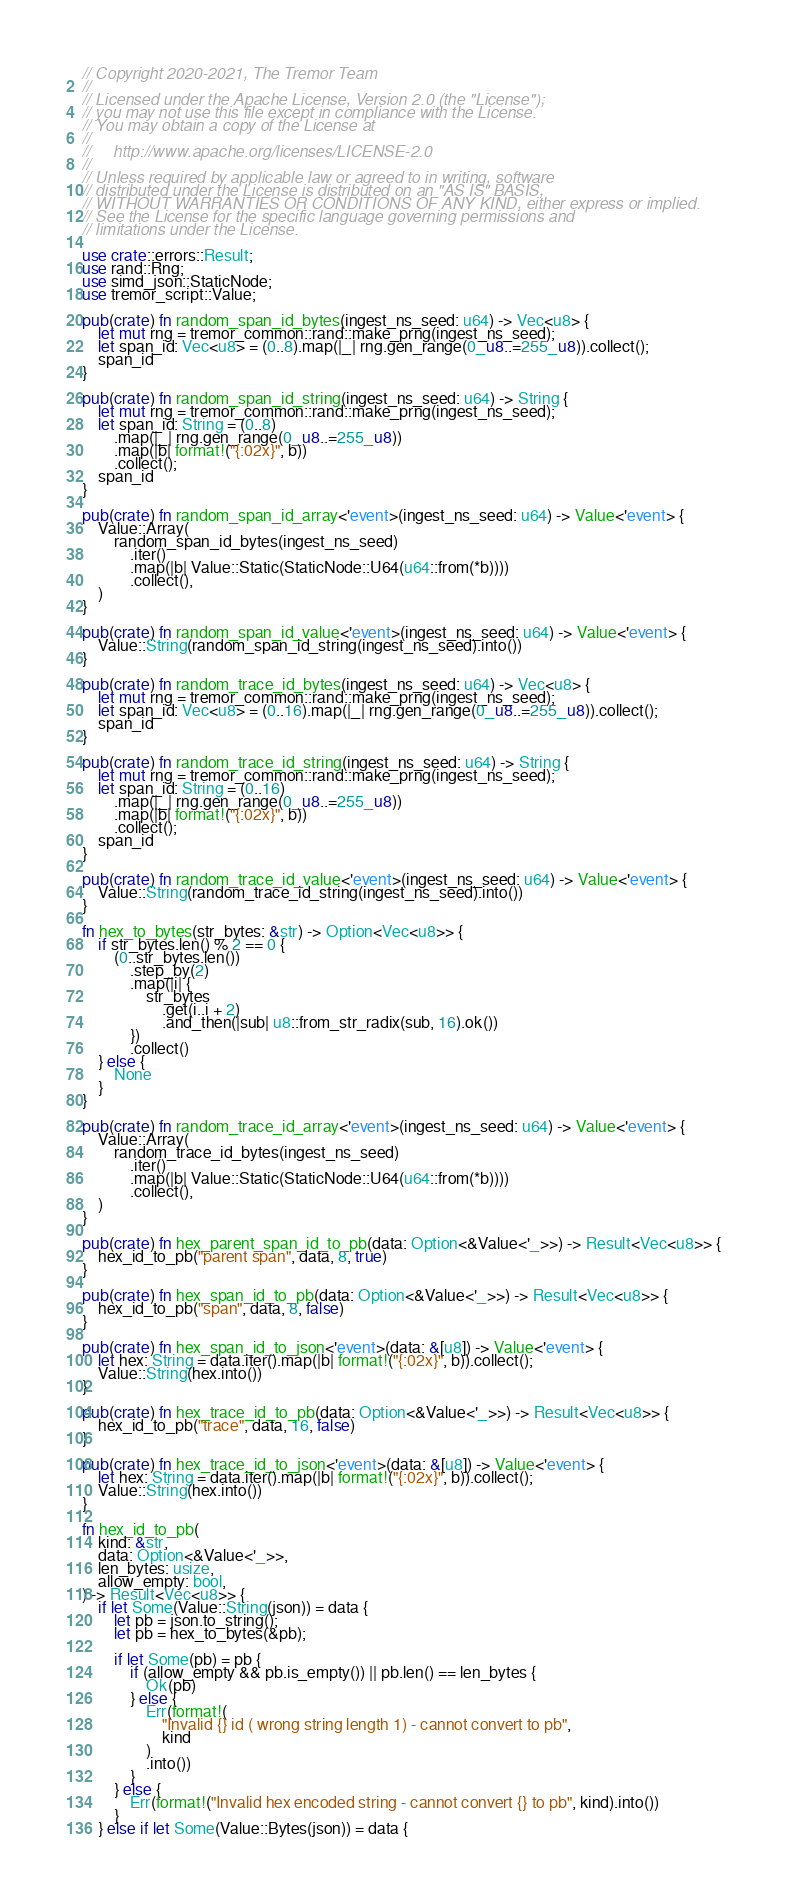<code> <loc_0><loc_0><loc_500><loc_500><_Rust_>// Copyright 2020-2021, The Tremor Team
//
// Licensed under the Apache License, Version 2.0 (the "License");
// you may not use this file except in compliance with the License.
// You may obtain a copy of the License at
//
//     http://www.apache.org/licenses/LICENSE-2.0
//
// Unless required by applicable law or agreed to in writing, software
// distributed under the License is distributed on an "AS IS" BASIS,
// WITHOUT WARRANTIES OR CONDITIONS OF ANY KIND, either express or implied.
// See the License for the specific language governing permissions and
// limitations under the License.

use crate::errors::Result;
use rand::Rng;
use simd_json::StaticNode;
use tremor_script::Value;

pub(crate) fn random_span_id_bytes(ingest_ns_seed: u64) -> Vec<u8> {
    let mut rng = tremor_common::rand::make_prng(ingest_ns_seed);
    let span_id: Vec<u8> = (0..8).map(|_| rng.gen_range(0_u8..=255_u8)).collect();
    span_id
}

pub(crate) fn random_span_id_string(ingest_ns_seed: u64) -> String {
    let mut rng = tremor_common::rand::make_prng(ingest_ns_seed);
    let span_id: String = (0..8)
        .map(|_| rng.gen_range(0_u8..=255_u8))
        .map(|b| format!("{:02x}", b))
        .collect();
    span_id
}

pub(crate) fn random_span_id_array<'event>(ingest_ns_seed: u64) -> Value<'event> {
    Value::Array(
        random_span_id_bytes(ingest_ns_seed)
            .iter()
            .map(|b| Value::Static(StaticNode::U64(u64::from(*b))))
            .collect(),
    )
}

pub(crate) fn random_span_id_value<'event>(ingest_ns_seed: u64) -> Value<'event> {
    Value::String(random_span_id_string(ingest_ns_seed).into())
}

pub(crate) fn random_trace_id_bytes(ingest_ns_seed: u64) -> Vec<u8> {
    let mut rng = tremor_common::rand::make_prng(ingest_ns_seed);
    let span_id: Vec<u8> = (0..16).map(|_| rng.gen_range(0_u8..=255_u8)).collect();
    span_id
}

pub(crate) fn random_trace_id_string(ingest_ns_seed: u64) -> String {
    let mut rng = tremor_common::rand::make_prng(ingest_ns_seed);
    let span_id: String = (0..16)
        .map(|_| rng.gen_range(0_u8..=255_u8))
        .map(|b| format!("{:02x}", b))
        .collect();
    span_id
}

pub(crate) fn random_trace_id_value<'event>(ingest_ns_seed: u64) -> Value<'event> {
    Value::String(random_trace_id_string(ingest_ns_seed).into())
}

fn hex_to_bytes(str_bytes: &str) -> Option<Vec<u8>> {
    if str_bytes.len() % 2 == 0 {
        (0..str_bytes.len())
            .step_by(2)
            .map(|i| {
                str_bytes
                    .get(i..i + 2)
                    .and_then(|sub| u8::from_str_radix(sub, 16).ok())
            })
            .collect()
    } else {
        None
    }
}

pub(crate) fn random_trace_id_array<'event>(ingest_ns_seed: u64) -> Value<'event> {
    Value::Array(
        random_trace_id_bytes(ingest_ns_seed)
            .iter()
            .map(|b| Value::Static(StaticNode::U64(u64::from(*b))))
            .collect(),
    )
}

pub(crate) fn hex_parent_span_id_to_pb(data: Option<&Value<'_>>) -> Result<Vec<u8>> {
    hex_id_to_pb("parent span", data, 8, true)
}

pub(crate) fn hex_span_id_to_pb(data: Option<&Value<'_>>) -> Result<Vec<u8>> {
    hex_id_to_pb("span", data, 8, false)
}

pub(crate) fn hex_span_id_to_json<'event>(data: &[u8]) -> Value<'event> {
    let hex: String = data.iter().map(|b| format!("{:02x}", b)).collect();
    Value::String(hex.into())
}

pub(crate) fn hex_trace_id_to_pb(data: Option<&Value<'_>>) -> Result<Vec<u8>> {
    hex_id_to_pb("trace", data, 16, false)
}

pub(crate) fn hex_trace_id_to_json<'event>(data: &[u8]) -> Value<'event> {
    let hex: String = data.iter().map(|b| format!("{:02x}", b)).collect();
    Value::String(hex.into())
}

fn hex_id_to_pb(
    kind: &str,
    data: Option<&Value<'_>>,
    len_bytes: usize,
    allow_empty: bool,
) -> Result<Vec<u8>> {
    if let Some(Value::String(json)) = data {
        let pb = json.to_string();
        let pb = hex_to_bytes(&pb);

        if let Some(pb) = pb {
            if (allow_empty && pb.is_empty()) || pb.len() == len_bytes {
                Ok(pb)
            } else {
                Err(format!(
                    "Invalid {} id ( wrong string length 1) - cannot convert to pb",
                    kind
                )
                .into())
            }
        } else {
            Err(format!("Invalid hex encoded string - cannot convert {} to pb", kind).into())
        }
    } else if let Some(Value::Bytes(json)) = data {</code> 